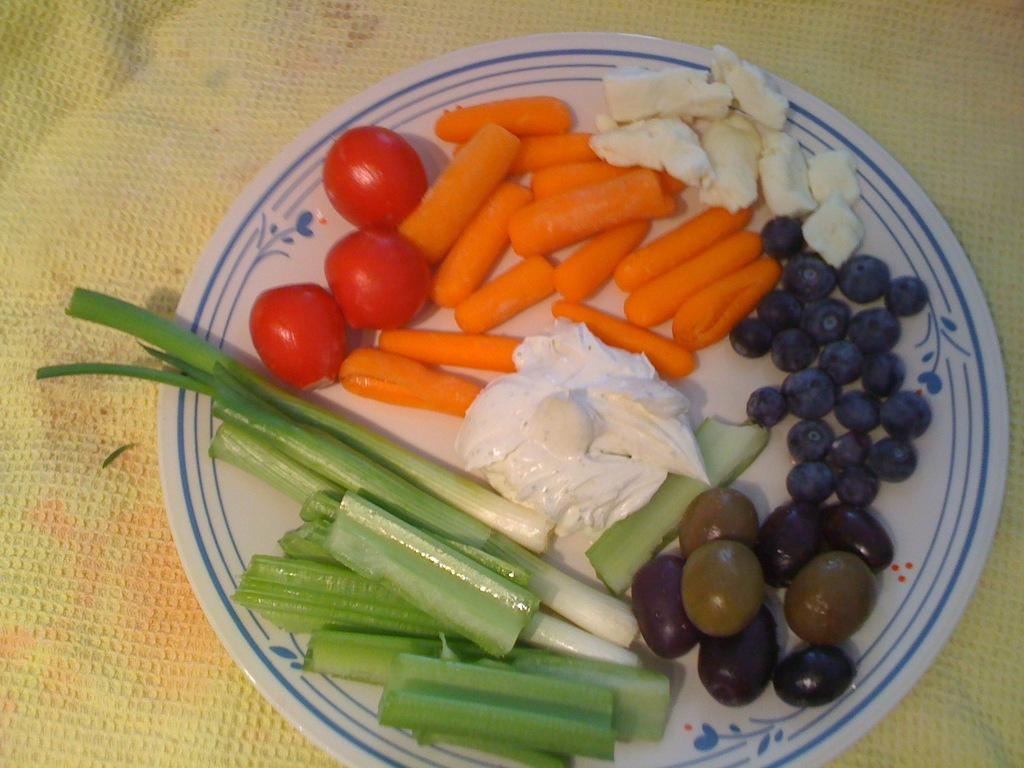What is on the plate in the image? There are food items in the plate. What color is the background of the image? The background color of the image is cream. What type of prison can be seen in the image? There is no prison present in the image; it only features a plate with food items and a cream-colored background. 